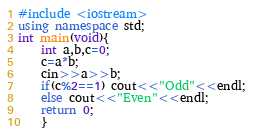Convert code to text. <code><loc_0><loc_0><loc_500><loc_500><_C++_>#include <iostream>
using namespace std;
int main(void){
    int a,b,c=0;
    c=a*b;
    cin>>a>>b;
    if(c%2==1) cout<<"Odd"<<endl;
    else cout<<"Even"<<endl;
    return 0;
    }
</code> 